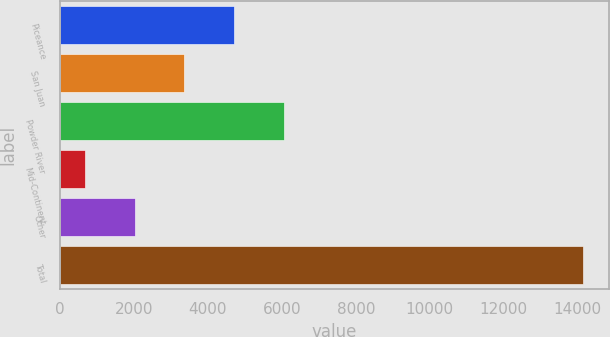Convert chart to OTSL. <chart><loc_0><loc_0><loc_500><loc_500><bar_chart><fcel>Piceance<fcel>San Juan<fcel>Powder River<fcel>Mid-Continent<fcel>Other<fcel>Total<nl><fcel>4714.4<fcel>3366.6<fcel>6062.2<fcel>671<fcel>2018.8<fcel>14149<nl></chart> 